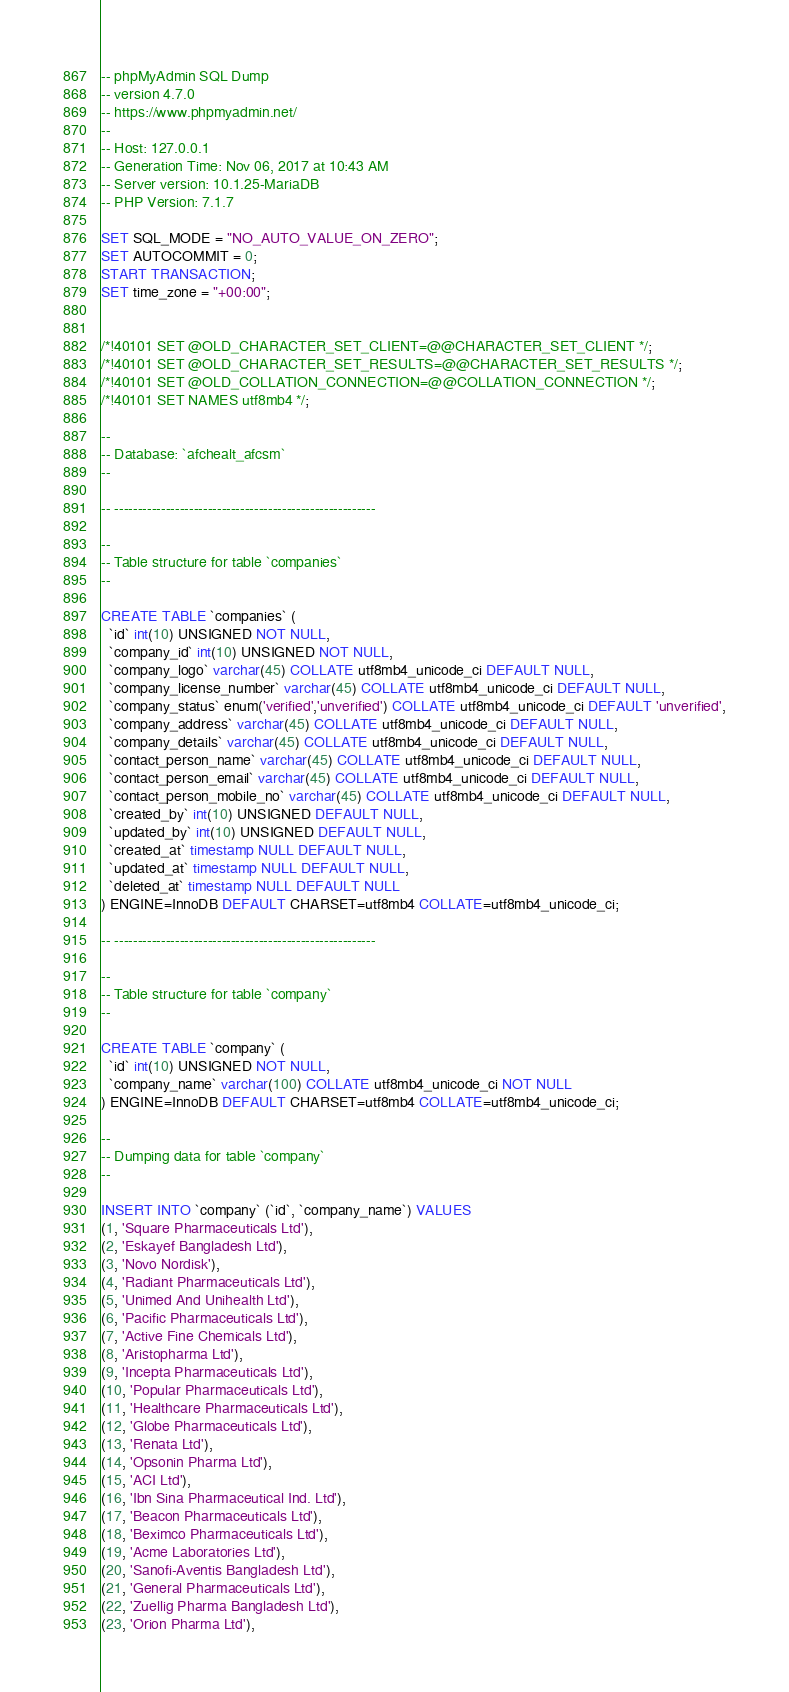<code> <loc_0><loc_0><loc_500><loc_500><_SQL_>-- phpMyAdmin SQL Dump
-- version 4.7.0
-- https://www.phpmyadmin.net/
--
-- Host: 127.0.0.1
-- Generation Time: Nov 06, 2017 at 10:43 AM
-- Server version: 10.1.25-MariaDB
-- PHP Version: 7.1.7

SET SQL_MODE = "NO_AUTO_VALUE_ON_ZERO";
SET AUTOCOMMIT = 0;
START TRANSACTION;
SET time_zone = "+00:00";


/*!40101 SET @OLD_CHARACTER_SET_CLIENT=@@CHARACTER_SET_CLIENT */;
/*!40101 SET @OLD_CHARACTER_SET_RESULTS=@@CHARACTER_SET_RESULTS */;
/*!40101 SET @OLD_COLLATION_CONNECTION=@@COLLATION_CONNECTION */;
/*!40101 SET NAMES utf8mb4 */;

--
-- Database: `afchealt_afcsm`
--

-- --------------------------------------------------------

--
-- Table structure for table `companies`
--

CREATE TABLE `companies` (
  `id` int(10) UNSIGNED NOT NULL,
  `company_id` int(10) UNSIGNED NOT NULL,
  `company_logo` varchar(45) COLLATE utf8mb4_unicode_ci DEFAULT NULL,
  `company_license_number` varchar(45) COLLATE utf8mb4_unicode_ci DEFAULT NULL,
  `company_status` enum('verified','unverified') COLLATE utf8mb4_unicode_ci DEFAULT 'unverified',
  `company_address` varchar(45) COLLATE utf8mb4_unicode_ci DEFAULT NULL,
  `company_details` varchar(45) COLLATE utf8mb4_unicode_ci DEFAULT NULL,
  `contact_person_name` varchar(45) COLLATE utf8mb4_unicode_ci DEFAULT NULL,
  `contact_person_email` varchar(45) COLLATE utf8mb4_unicode_ci DEFAULT NULL,
  `contact_person_mobile_no` varchar(45) COLLATE utf8mb4_unicode_ci DEFAULT NULL,
  `created_by` int(10) UNSIGNED DEFAULT NULL,
  `updated_by` int(10) UNSIGNED DEFAULT NULL,
  `created_at` timestamp NULL DEFAULT NULL,
  `updated_at` timestamp NULL DEFAULT NULL,
  `deleted_at` timestamp NULL DEFAULT NULL
) ENGINE=InnoDB DEFAULT CHARSET=utf8mb4 COLLATE=utf8mb4_unicode_ci;

-- --------------------------------------------------------

--
-- Table structure for table `company`
--

CREATE TABLE `company` (
  `id` int(10) UNSIGNED NOT NULL,
  `company_name` varchar(100) COLLATE utf8mb4_unicode_ci NOT NULL
) ENGINE=InnoDB DEFAULT CHARSET=utf8mb4 COLLATE=utf8mb4_unicode_ci;

--
-- Dumping data for table `company`
--

INSERT INTO `company` (`id`, `company_name`) VALUES
(1, 'Square Pharmaceuticals Ltd'),
(2, 'Eskayef Bangladesh Ltd'),
(3, 'Novo Nordisk'),
(4, 'Radiant Pharmaceuticals Ltd'),
(5, 'Unimed And Unihealth Ltd'),
(6, 'Pacific Pharmaceuticals Ltd'),
(7, 'Active Fine Chemicals Ltd'),
(8, 'Aristopharma Ltd'),
(9, 'Incepta Pharmaceuticals Ltd'),
(10, 'Popular Pharmaceuticals Ltd'),
(11, 'Healthcare Pharmaceuticals Ltd'),
(12, 'Globe Pharmaceuticals Ltd'),
(13, 'Renata Ltd'),
(14, 'Opsonin Pharma Ltd'),
(15, 'ACI Ltd'),
(16, 'Ibn Sina Pharmaceutical Ind. Ltd'),
(17, 'Beacon Pharmaceuticals Ltd'),
(18, 'Beximco Pharmaceuticals Ltd'),
(19, 'Acme Laboratories Ltd'),
(20, 'Sanofi-Aventis Bangladesh Ltd'),
(21, 'General Pharmaceuticals Ltd'),
(22, 'Zuellig Pharma Bangladesh Ltd'),
(23, 'Orion Pharma Ltd'),</code> 